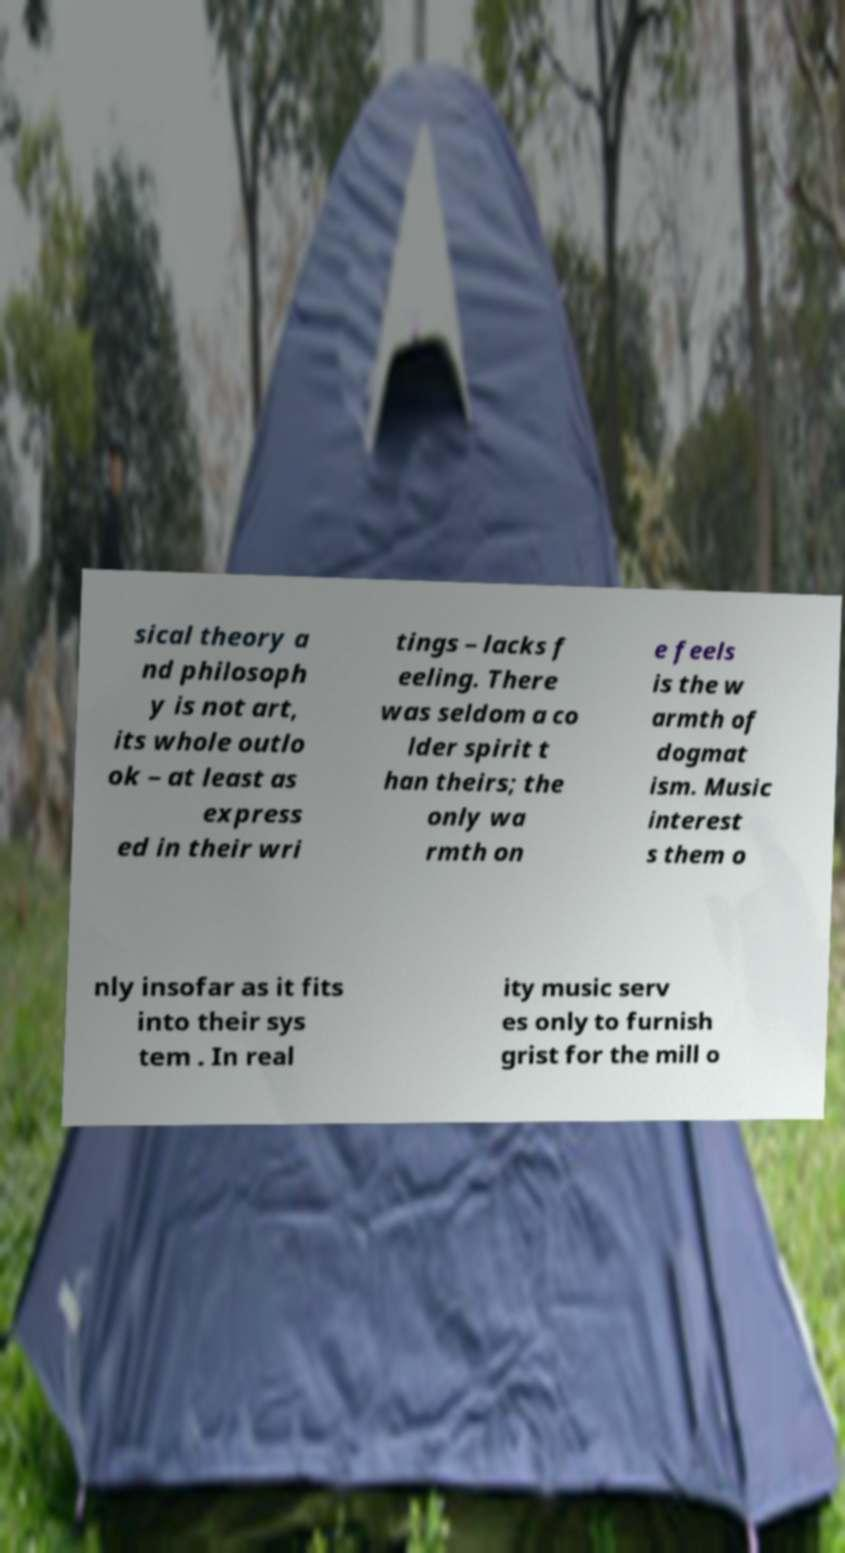Can you read and provide the text displayed in the image?This photo seems to have some interesting text. Can you extract and type it out for me? sical theory a nd philosoph y is not art, its whole outlo ok – at least as express ed in their wri tings – lacks f eeling. There was seldom a co lder spirit t han theirs; the only wa rmth on e feels is the w armth of dogmat ism. Music interest s them o nly insofar as it fits into their sys tem . In real ity music serv es only to furnish grist for the mill o 